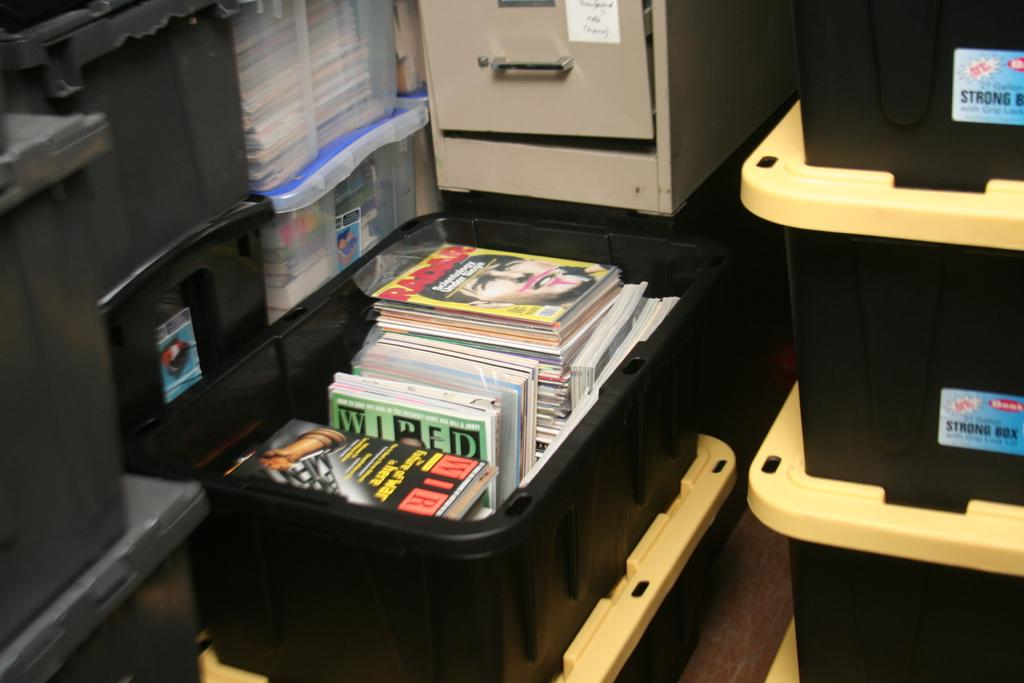Provide a one-sentence caption for the provided image. The magazine on top of the pile is by Radar. 